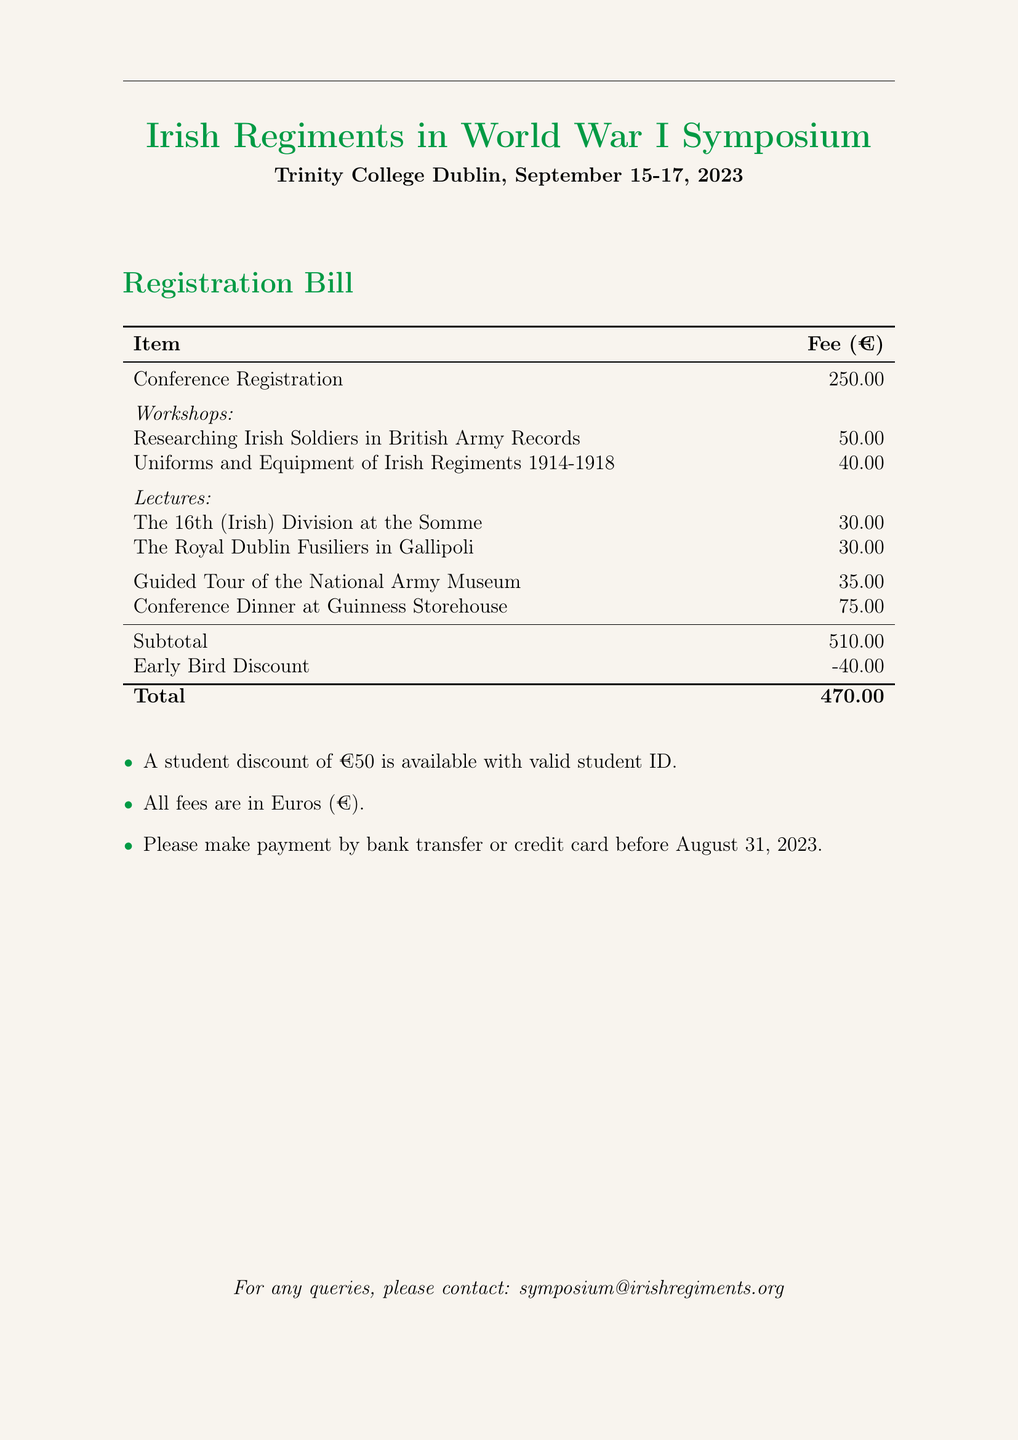What is the location of the symposium? The document states that the symposium will be held at Trinity College Dublin.
Answer: Trinity College Dublin What is the date range of the event? The event occurs from September 15 to September 17, 2023, as specified in the document.
Answer: September 15-17, 2023 What is the fee for the guided tour? The fee for the guided tour of the National Army Museum is listed in the fees table.
Answer: 35.00 How much is the early bird discount? The document mentions an early bird discount of €40 under the subtotal section.
Answer: -40.00 What is the total amount after the discount? The total fee after applying the early bird discount is shown in the document.
Answer: 470.00 Is there a student discount available? There is a note in the document indicating that a student discount is available.
Answer: Yes, €50 What is the registration fee for the conference? The registration fee is clearly stated in the fees table of the document.
Answer: 250.00 What are the workshop topics offered? The document lists two specific workshops related to Irish soldiers and regiments.
Answer: Researching Irish Soldiers, Uniforms and Equipment What payment methods are accepted? The document mentions that payments can be made by bank transfer or credit card.
Answer: Bank transfer or credit card 